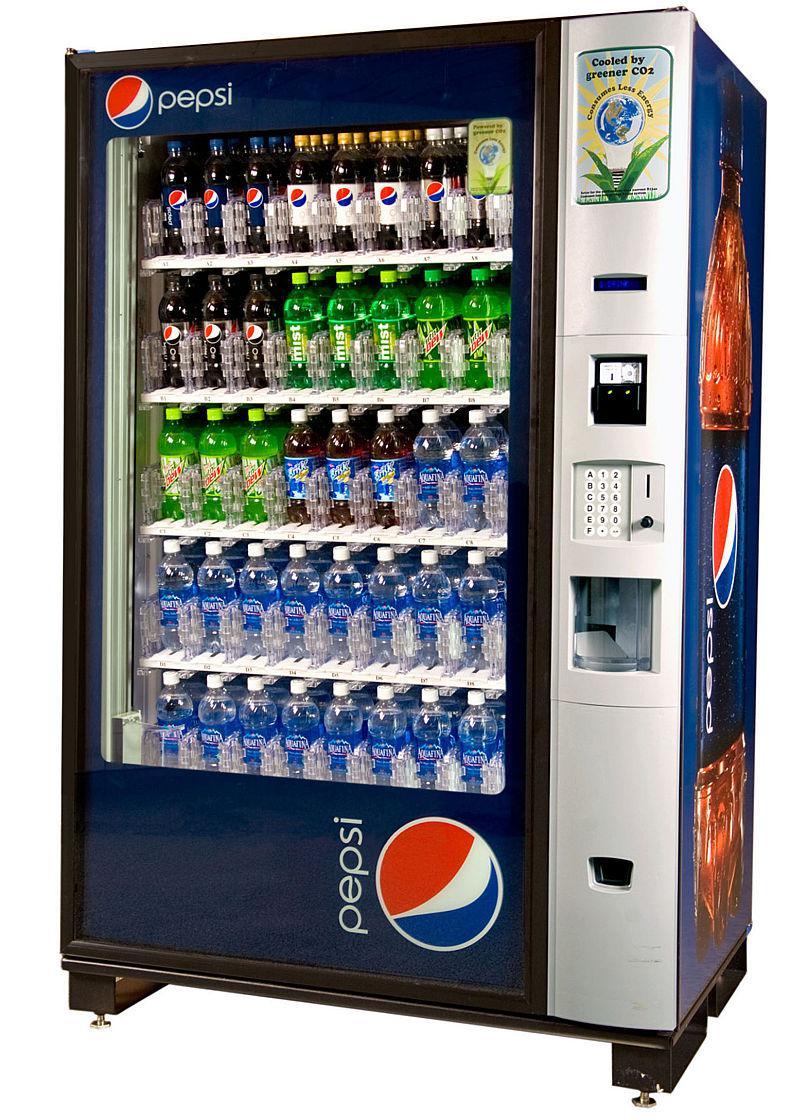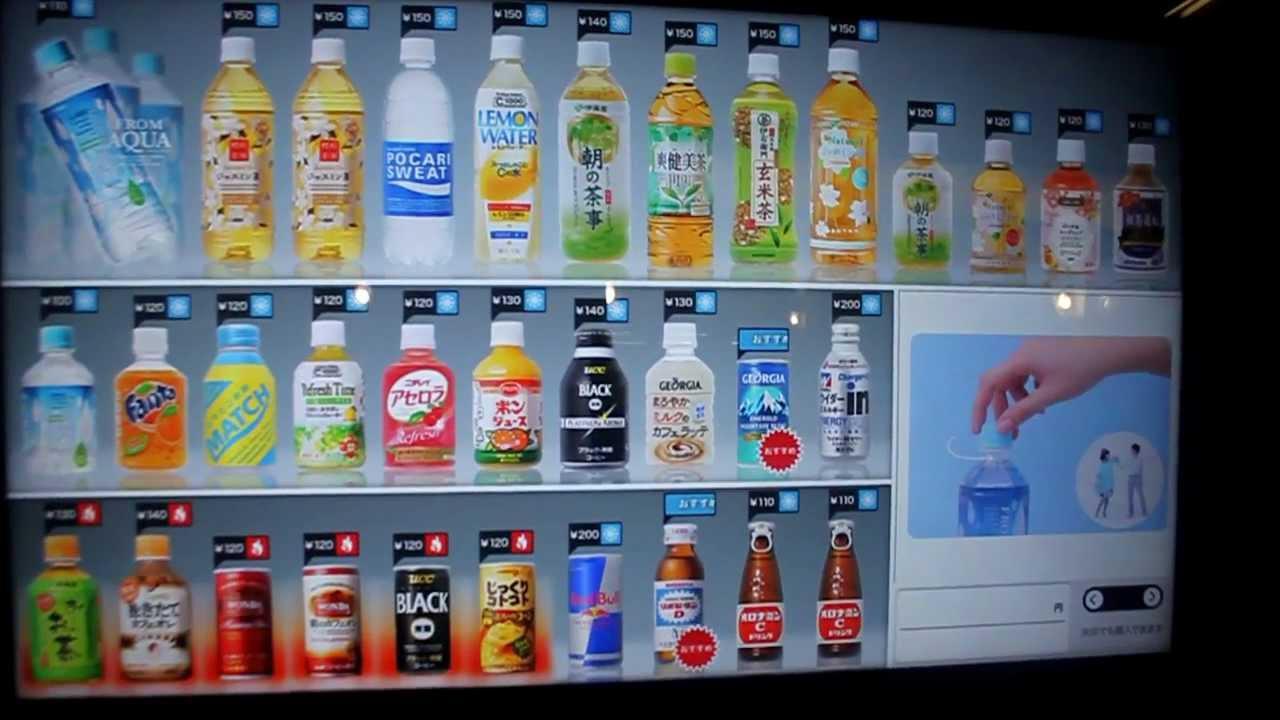The first image is the image on the left, the second image is the image on the right. Assess this claim about the two images: "In one image there is a vending machine filled with a selection bottles of various beverages for customers to choose from.". Correct or not? Answer yes or no. Yes. The first image is the image on the left, the second image is the image on the right. For the images displayed, is the sentence "There is at least one vending machine with the Pepsi logo on it." factually correct? Answer yes or no. Yes. 